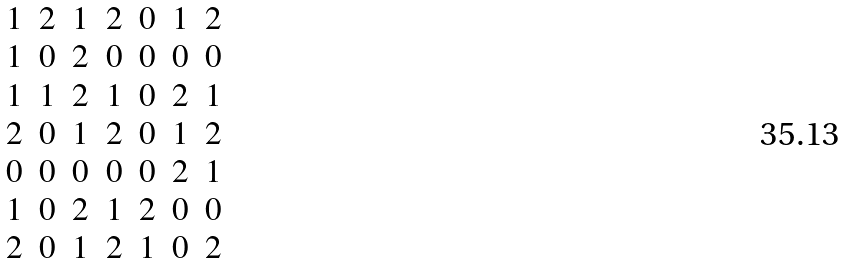<formula> <loc_0><loc_0><loc_500><loc_500>\begin{matrix} 1 & 2 & 1 & 2 & 0 & 1 & 2 \\ 1 & 0 & 2 & 0 & 0 & 0 & 0 \\ 1 & 1 & 2 & 1 & 0 & 2 & 1 \\ 2 & 0 & 1 & 2 & 0 & 1 & 2 \\ 0 & 0 & 0 & 0 & 0 & 2 & 1 \\ 1 & 0 & 2 & 1 & 2 & 0 & 0 \\ 2 & 0 & 1 & 2 & 1 & 0 & 2 \end{matrix}</formula> 